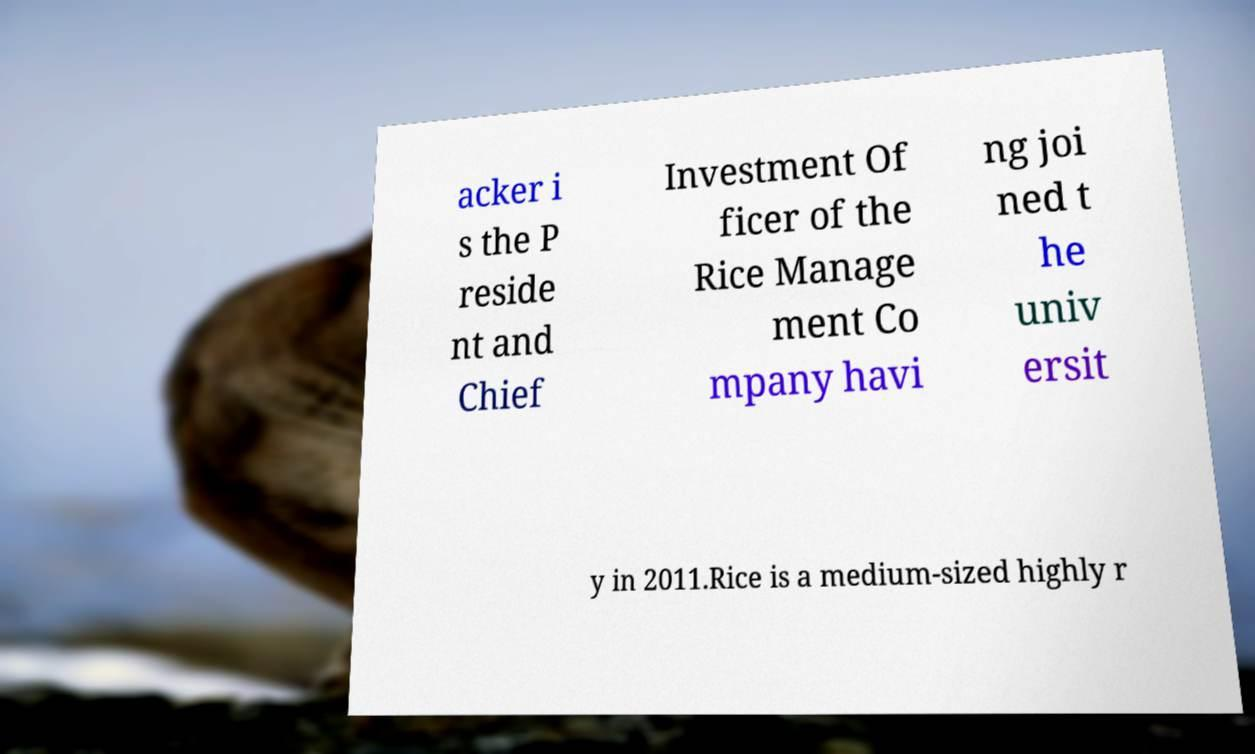For documentation purposes, I need the text within this image transcribed. Could you provide that? acker i s the P reside nt and Chief Investment Of ficer of the Rice Manage ment Co mpany havi ng joi ned t he univ ersit y in 2011.Rice is a medium-sized highly r 